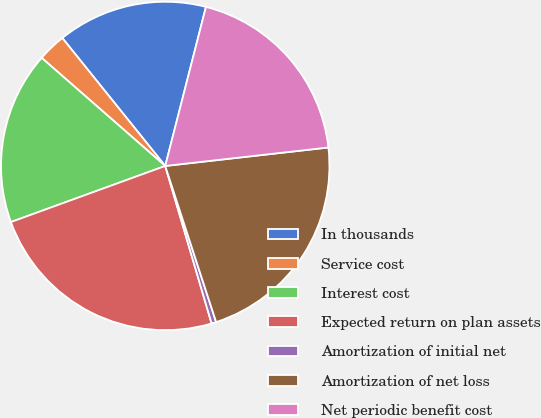Convert chart to OTSL. <chart><loc_0><loc_0><loc_500><loc_500><pie_chart><fcel>In thousands<fcel>Service cost<fcel>Interest cost<fcel>Expected return on plan assets<fcel>Amortization of initial net<fcel>Amortization of net loss<fcel>Net periodic benefit cost<nl><fcel>14.77%<fcel>2.78%<fcel>16.99%<fcel>24.01%<fcel>0.46%<fcel>21.78%<fcel>19.22%<nl></chart> 